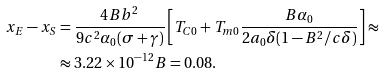<formula> <loc_0><loc_0><loc_500><loc_500>x _ { E } - x _ { S } & = \frac { 4 B b ^ { 2 } } { 9 c ^ { 2 } \alpha _ { 0 } ( \sigma + \gamma ) } \left [ T _ { C 0 } + T _ { m 0 } \frac { B \alpha _ { 0 } } { 2 a _ { 0 } \delta ( 1 - B ^ { 2 } / c \delta ) } \right ] \approx \\ & \approx 3 . 2 2 \times 1 0 ^ { - 1 2 } B = 0 . 0 8 .</formula> 